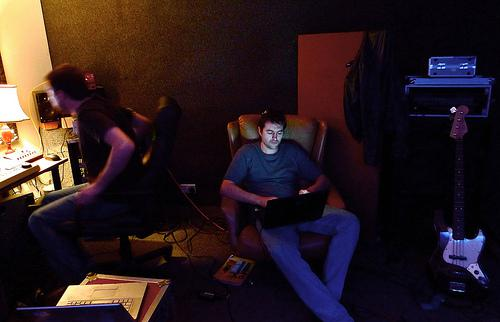Question: how many males in the picture?
Choices:
A. 3.
B. 2.
C. 4.
D. 5.
Answer with the letter. Answer: B Question: what instrument is shown?
Choices:
A. Violin.
B. Guitar.
C. Cello.
D. Flute.
Answer with the letter. Answer: B Question: what kind of pants are the men wearing?
Choices:
A. Jogging.
B. Jeans.
C. Sweat.
D. Khakis.
Answer with the letter. Answer: B 